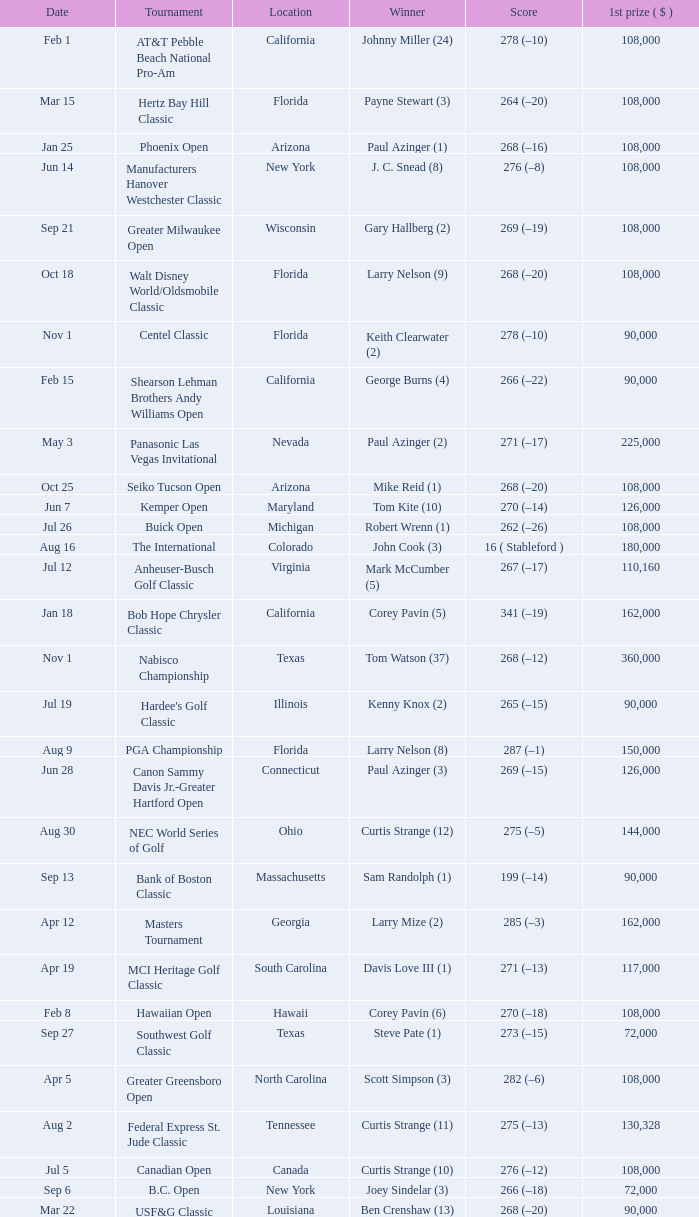What is the score from the winner Keith Clearwater (1)? 266 (–14). 